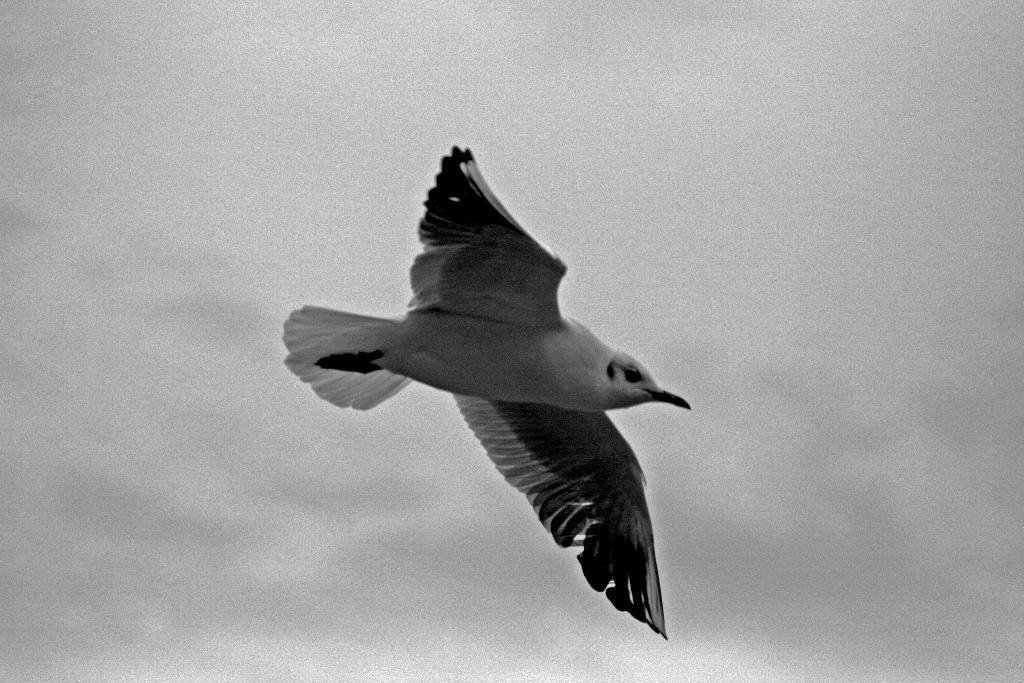In one or two sentences, can you explain what this image depicts? This picture shows a bird flying in the sky. 